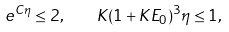Convert formula to latex. <formula><loc_0><loc_0><loc_500><loc_500>e ^ { C \eta } \leq 2 , \quad K ( 1 + K E _ { 0 } ) ^ { 3 } \eta \leq 1 ,</formula> 